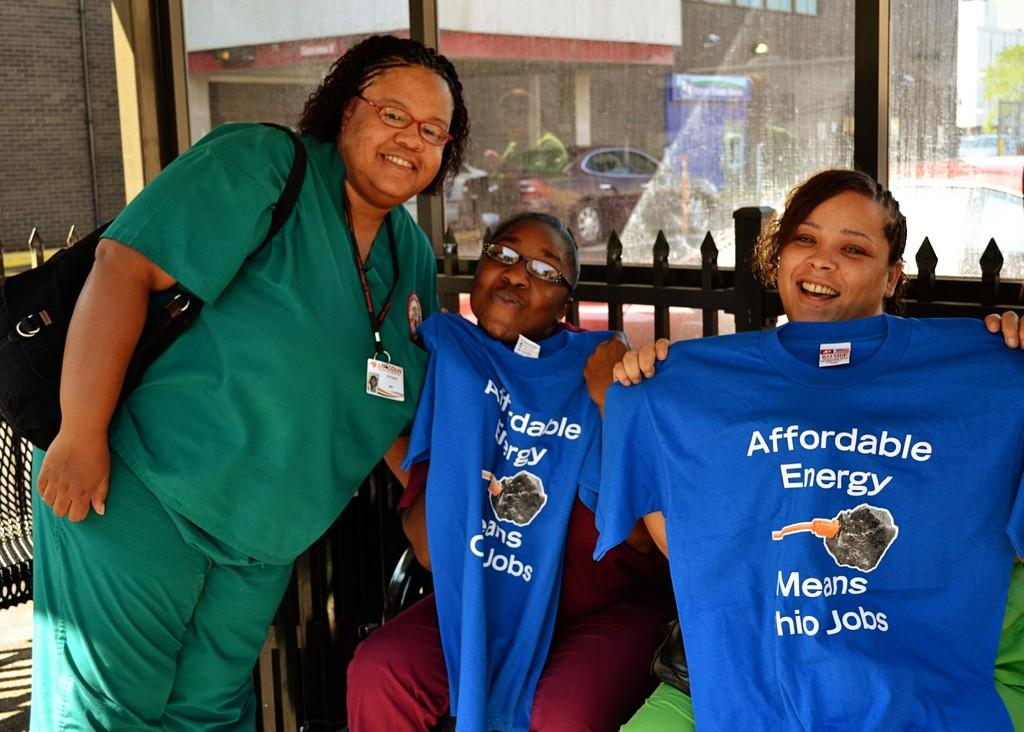How many people are in the image? There are three people in the image. What can be seen in the image besides the people? Clothes, a wall, and a glass element} are visible in the image. What is visible through the glass element? A car, boards, and a building are visible through the glass element. Where is the stick located in the image? There is no stick present in the image. Who is sitting on the throne in the image? There is no throne present in the image. 